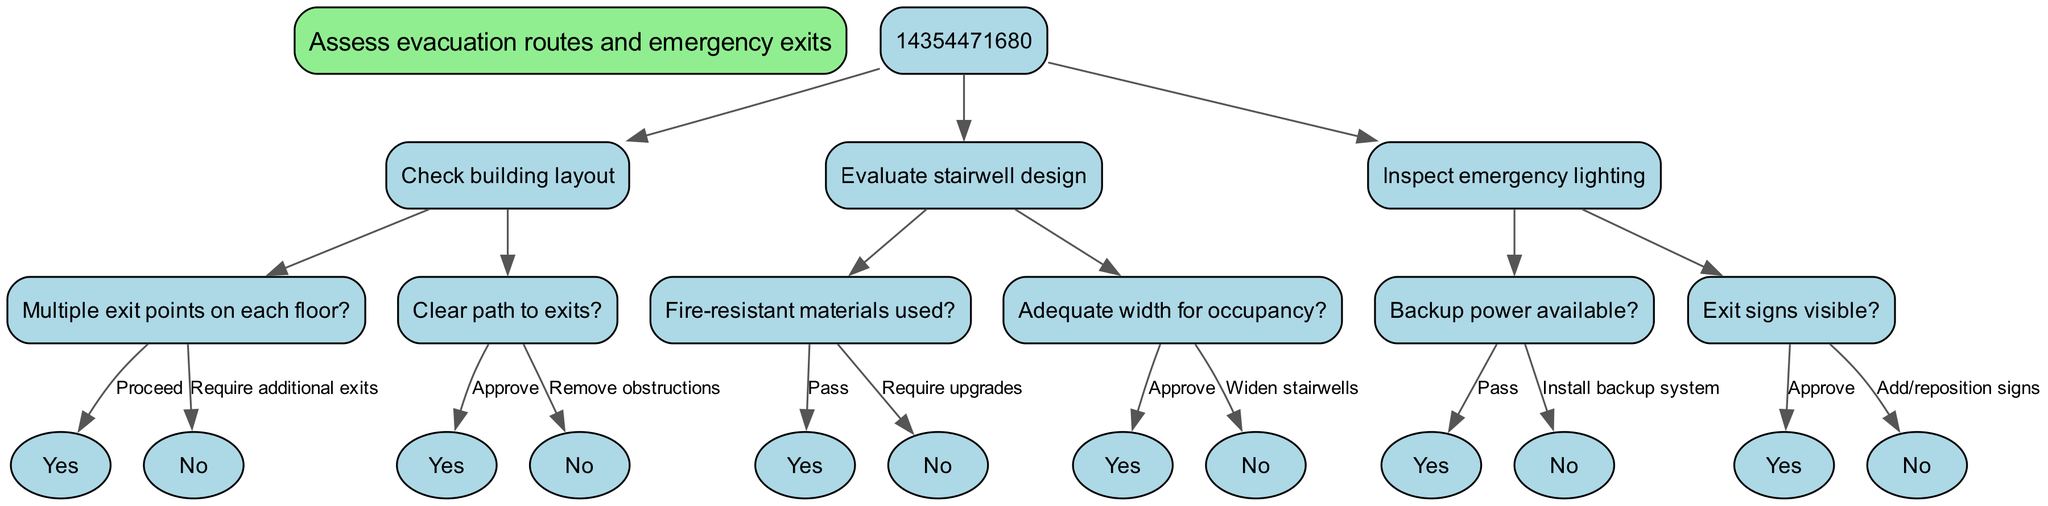What is the root node of the diagram? The root node is labeled "Assess evacuation routes and emergency exits". This is the primary starting point of the decision tree, indicating the overall focus of the evaluation.
Answer: Assess evacuation routes and emergency exits How many main sections are there in this decision tree? The decision tree features three main sections: "Check building layout", "Evaluate stairwell design", and "Inspect emergency lighting". Each of these sections explores different facets of the evacuation assessment.
Answer: 3 What is the edge label associated with needing additional exits? The label for the edge indicating the situation of not having multiple exit points on each floor leads to the requirement for additional exits, which highlights the necessity for better emergency exit accessibility.
Answer: Require additional exits If the path to exits is clear, what is the next step? If the path to exits is clear, the decision tree directs to "Approve", indicating that this aspect of the evacuation route assessment meets the required standards for safety.
Answer: Approve What is the consequence if fire-resistant materials are not used? If fire-resistant materials are not used in the stairwell design, the tree stipulates that upgrades are required. This indicates a significant safety concern that must be addressed to ensure compliance.
Answer: Require upgrades How does one verify if backup power is available? The verification of backup power availability is crucial and is assessed through a direct question in the decision tree, which leads to either a pass or a requirement for installation if the answer is negative.
Answer: Pass (if available) / Install backup system (if not) What should be done if exit signs are not visible? If exit signs are not visible, the directive is to add or reposition signs. This emphasizes the importance of clear and visible exit signage in safe evacuations during emergencies.
Answer: Add/reposition signs What happens if stairwells are too narrow for occupancy? If the stairwells are found to be inadequate in width for the occupancy level, the decision tree mandates widening the stairwells, ensuring that they can accommodate safe egress for all building occupants.
Answer: Widen stairwells How many children nodes does the "Inspect emergency lighting" node have? The node "Inspect emergency lighting" has two children nodes: one for checking backup power availability and another for verifying the visibility of exit signs. This indicates the dual focus on functionality and clarity of emergency lighting.
Answer: 2 